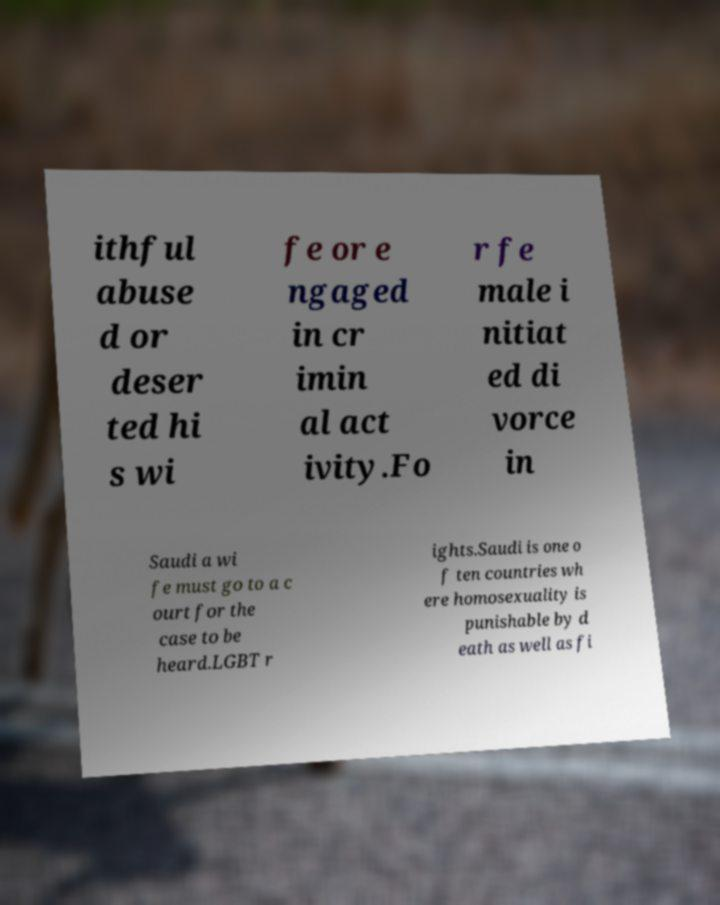Please read and relay the text visible in this image. What does it say? ithful abuse d or deser ted hi s wi fe or e ngaged in cr imin al act ivity.Fo r fe male i nitiat ed di vorce in Saudi a wi fe must go to a c ourt for the case to be heard.LGBT r ights.Saudi is one o f ten countries wh ere homosexuality is punishable by d eath as well as fi 